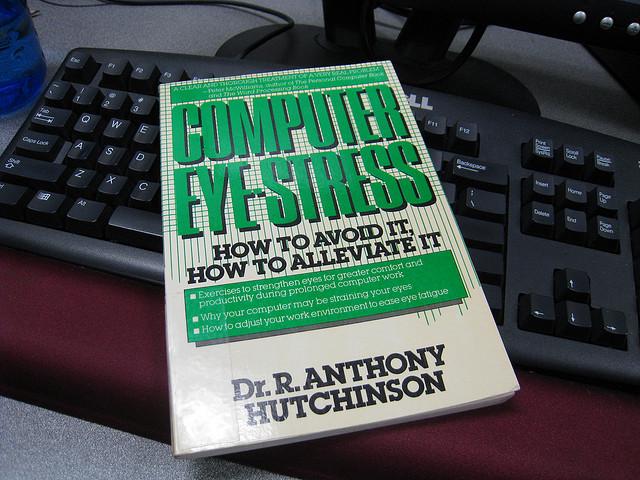Who made the keyboard?
Keep it brief. Dell. Are these instructions for a cell phone?
Keep it brief. No. Is it a good idea to read the book before using the computer?
Quick response, please. Yes. Where is a globe?
Short answer required. No globe. Who is the author of this book?
Answer briefly. Dr r anthony hutchinson. 